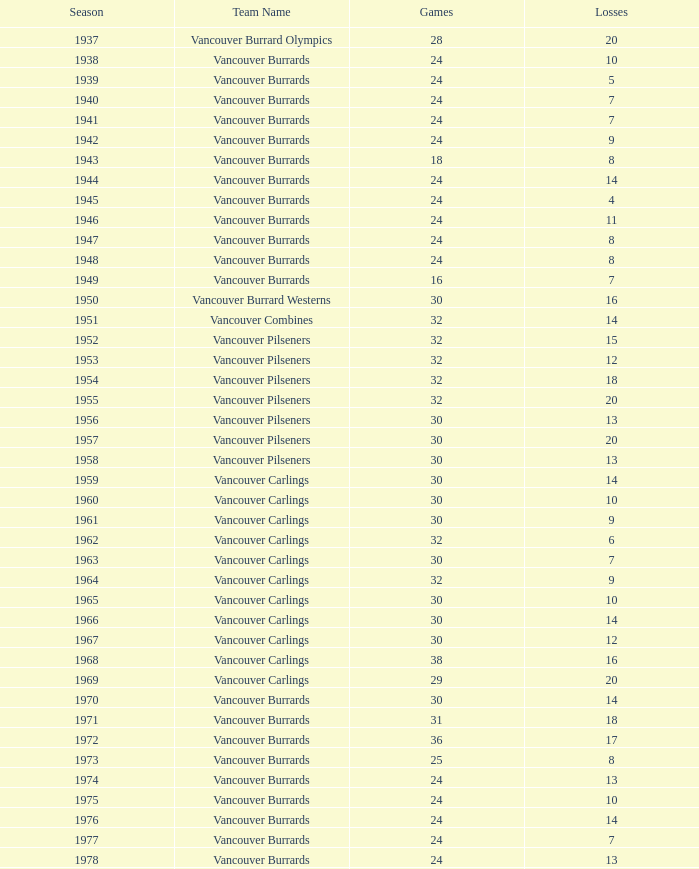What is the cumulative point count when the vancouver burrards experience under 9 losses and beyond 24 games? 1.0. 